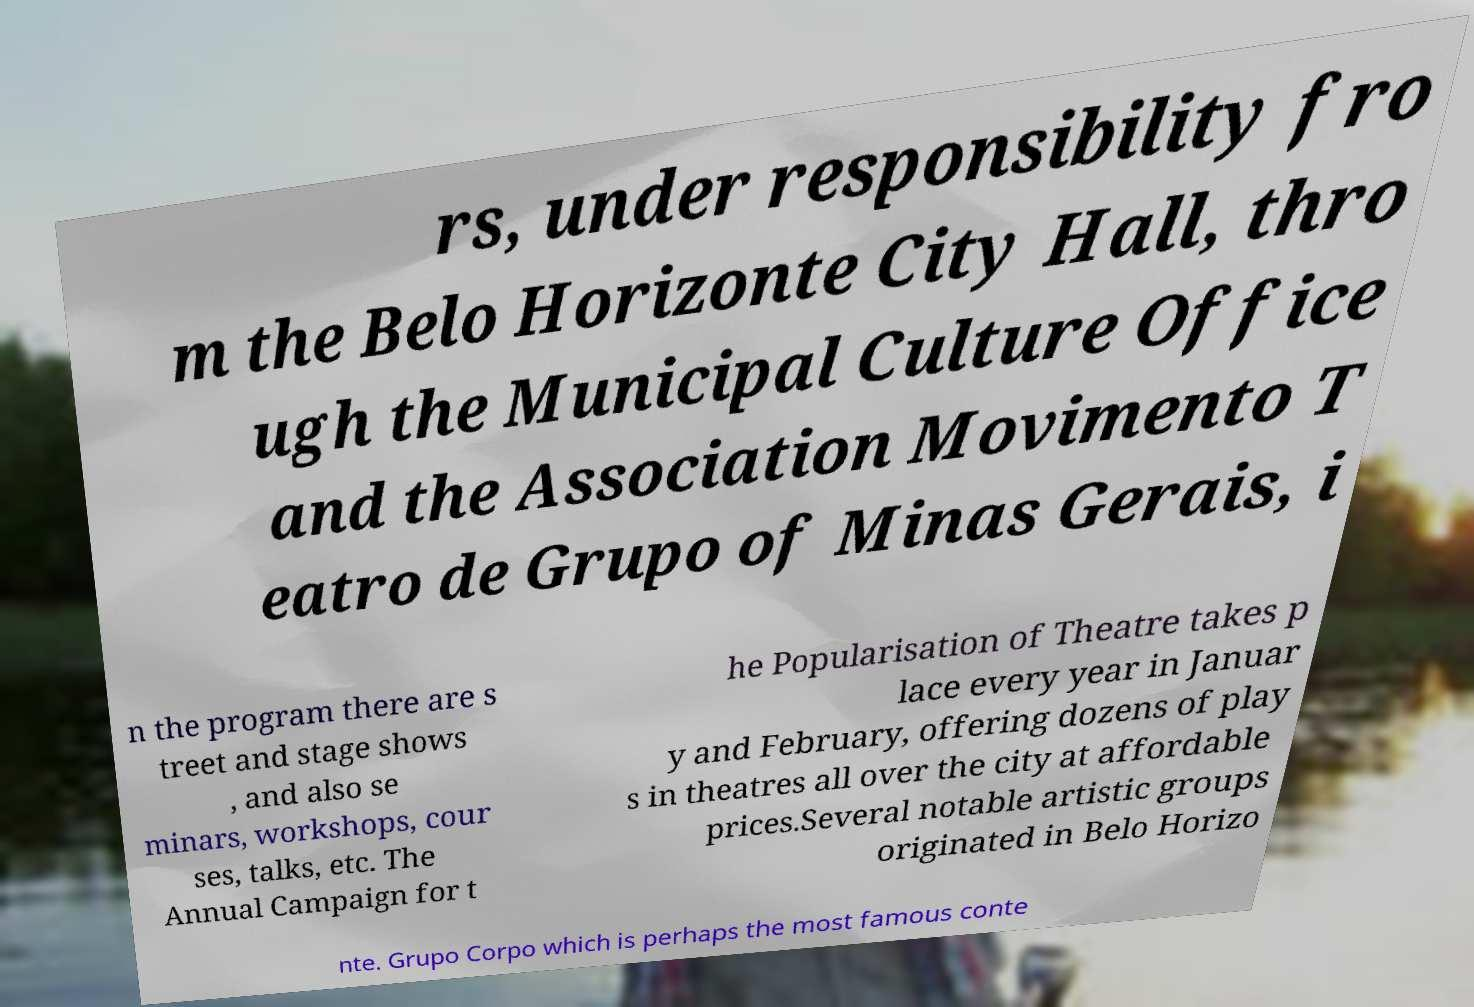I need the written content from this picture converted into text. Can you do that? rs, under responsibility fro m the Belo Horizonte City Hall, thro ugh the Municipal Culture Office and the Association Movimento T eatro de Grupo of Minas Gerais, i n the program there are s treet and stage shows , and also se minars, workshops, cour ses, talks, etc. The Annual Campaign for t he Popularisation of Theatre takes p lace every year in Januar y and February, offering dozens of play s in theatres all over the city at affordable prices.Several notable artistic groups originated in Belo Horizo nte. Grupo Corpo which is perhaps the most famous conte 